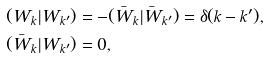Convert formula to latex. <formula><loc_0><loc_0><loc_500><loc_500>& ( W _ { k } | W _ { k ^ { \prime } } ) = - ( \bar { W } _ { k } | \bar { W } _ { k ^ { \prime } } ) = \delta ( k - k ^ { \prime } ) , \\ & ( \bar { W } _ { k } | W _ { k ^ { \prime } } ) = 0 ,</formula> 